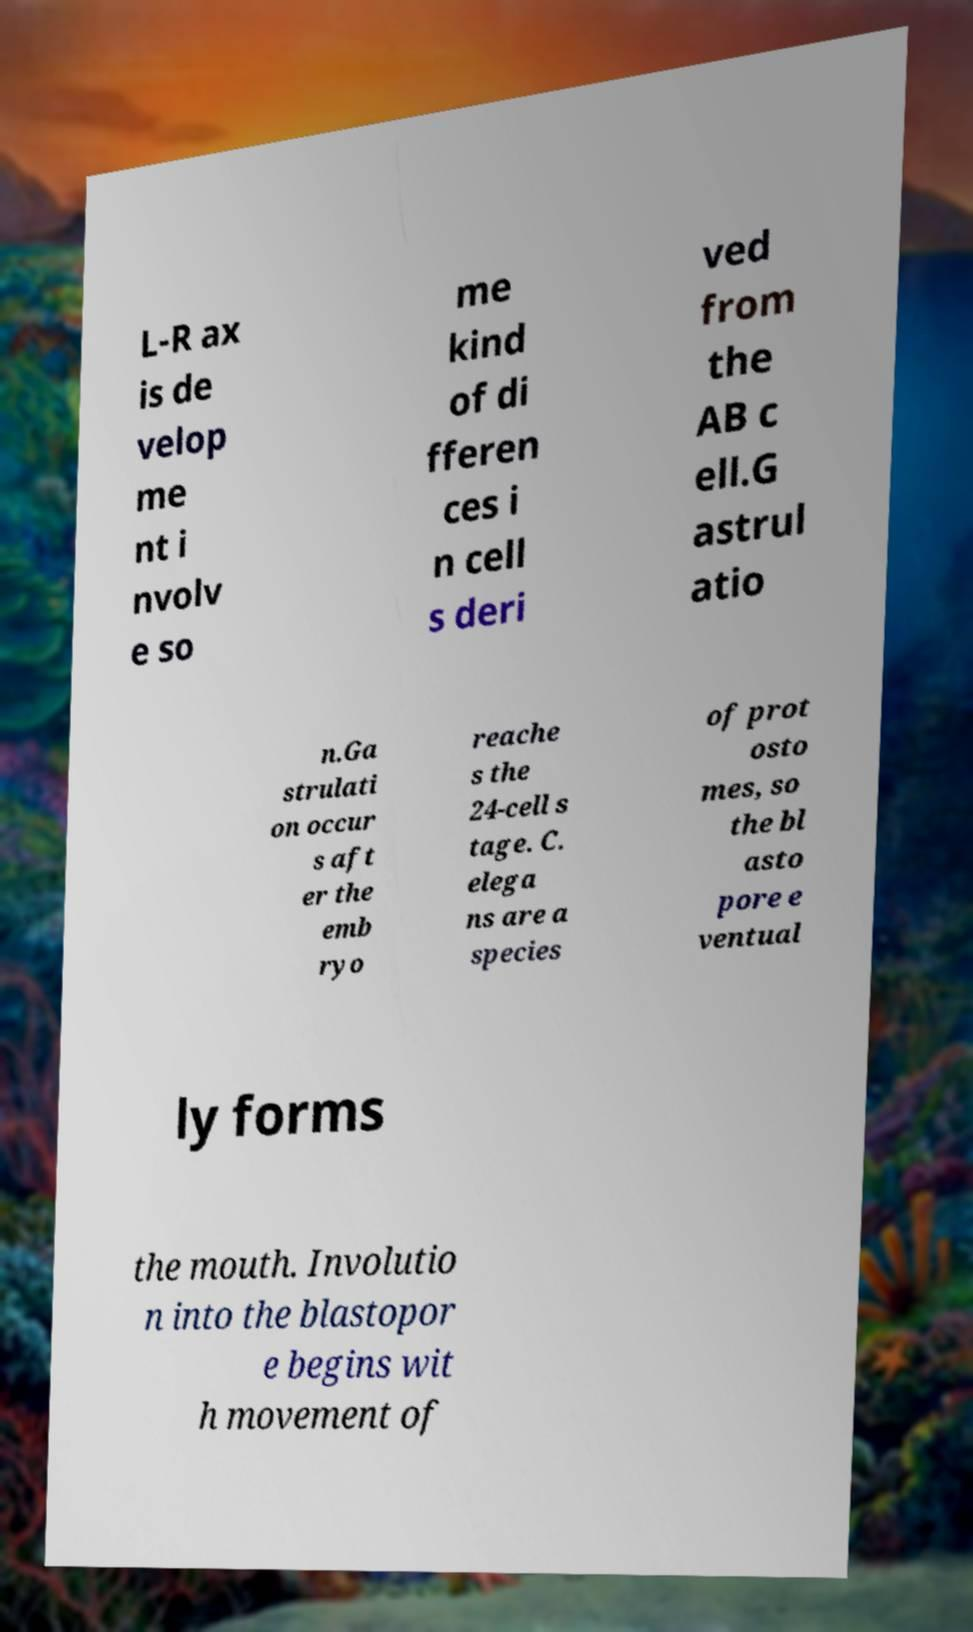For documentation purposes, I need the text within this image transcribed. Could you provide that? L-R ax is de velop me nt i nvolv e so me kind of di fferen ces i n cell s deri ved from the AB c ell.G astrul atio n.Ga strulati on occur s aft er the emb ryo reache s the 24-cell s tage. C. elega ns are a species of prot osto mes, so the bl asto pore e ventual ly forms the mouth. Involutio n into the blastopor e begins wit h movement of 